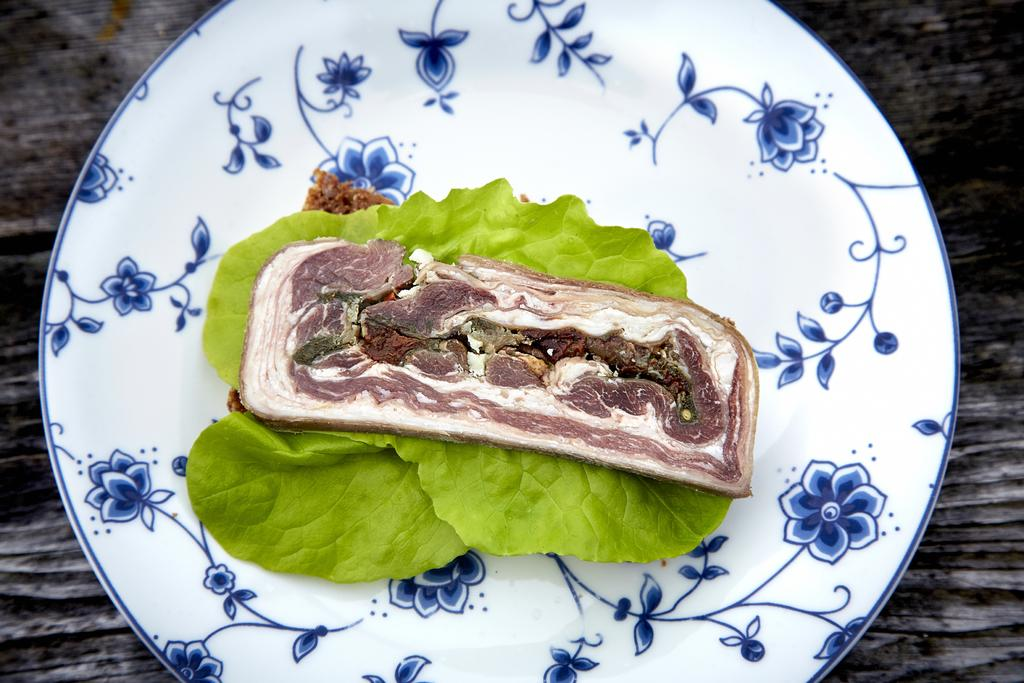What color is the plate that holds the food in the image? The plate is white. What type of food is on the plate? The food is not specified, but it is in a white color plate. What other items are present on the plate? There are green color leaves on the plate. On what surface is the plate placed? The plate is placed on a black color table. How does the pollution affect the food in the image? There is no mention of pollution in the image, so we cannot determine its effect on the food. 